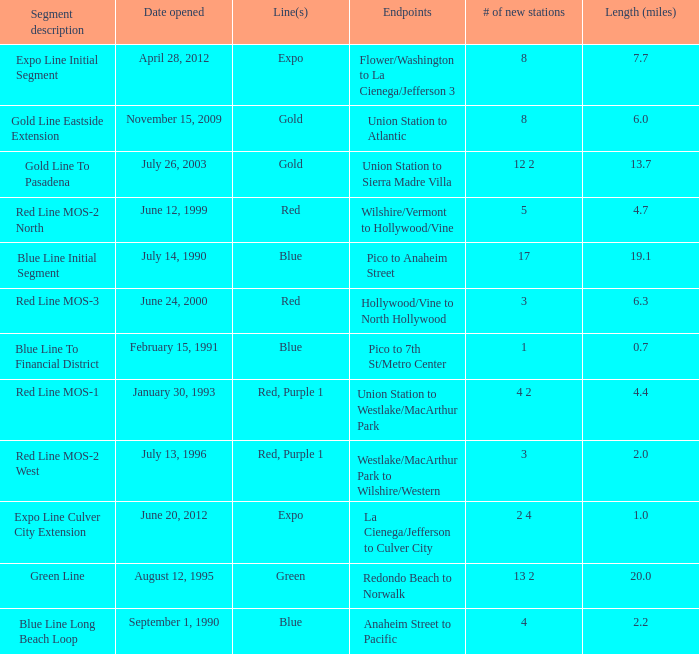Would you be able to parse every entry in this table? {'header': ['Segment description', 'Date opened', 'Line(s)', 'Endpoints', '# of new stations', 'Length (miles)'], 'rows': [['Expo Line Initial Segment', 'April 28, 2012', 'Expo', 'Flower/Washington to La Cienega/Jefferson 3', '8', '7.7'], ['Gold Line Eastside Extension', 'November 15, 2009', 'Gold', 'Union Station to Atlantic', '8', '6.0'], ['Gold Line To Pasadena', 'July 26, 2003', 'Gold', 'Union Station to Sierra Madre Villa', '12 2', '13.7'], ['Red Line MOS-2 North', 'June 12, 1999', 'Red', 'Wilshire/Vermont to Hollywood/Vine', '5', '4.7'], ['Blue Line Initial Segment', 'July 14, 1990', 'Blue', 'Pico to Anaheim Street', '17', '19.1'], ['Red Line MOS-3', 'June 24, 2000', 'Red', 'Hollywood/Vine to North Hollywood', '3', '6.3'], ['Blue Line To Financial District', 'February 15, 1991', 'Blue', 'Pico to 7th St/Metro Center', '1', '0.7'], ['Red Line MOS-1', 'January 30, 1993', 'Red, Purple 1', 'Union Station to Westlake/MacArthur Park', '4 2', '4.4'], ['Red Line MOS-2 West', 'July 13, 1996', 'Red, Purple 1', 'Westlake/MacArthur Park to Wilshire/Western', '3', '2.0'], ['Expo Line Culver City Extension', 'June 20, 2012', 'Expo', 'La Cienega/Jefferson to Culver City', '2 4', '1.0'], ['Green Line', 'August 12, 1995', 'Green', 'Redondo Beach to Norwalk', '13 2', '20.0'], ['Blue Line Long Beach Loop', 'September 1, 1990', 'Blue', 'Anaheim Street to Pacific', '4', '2.2']]} How many new stations have a lenght (miles) of 6.0? 1.0. 